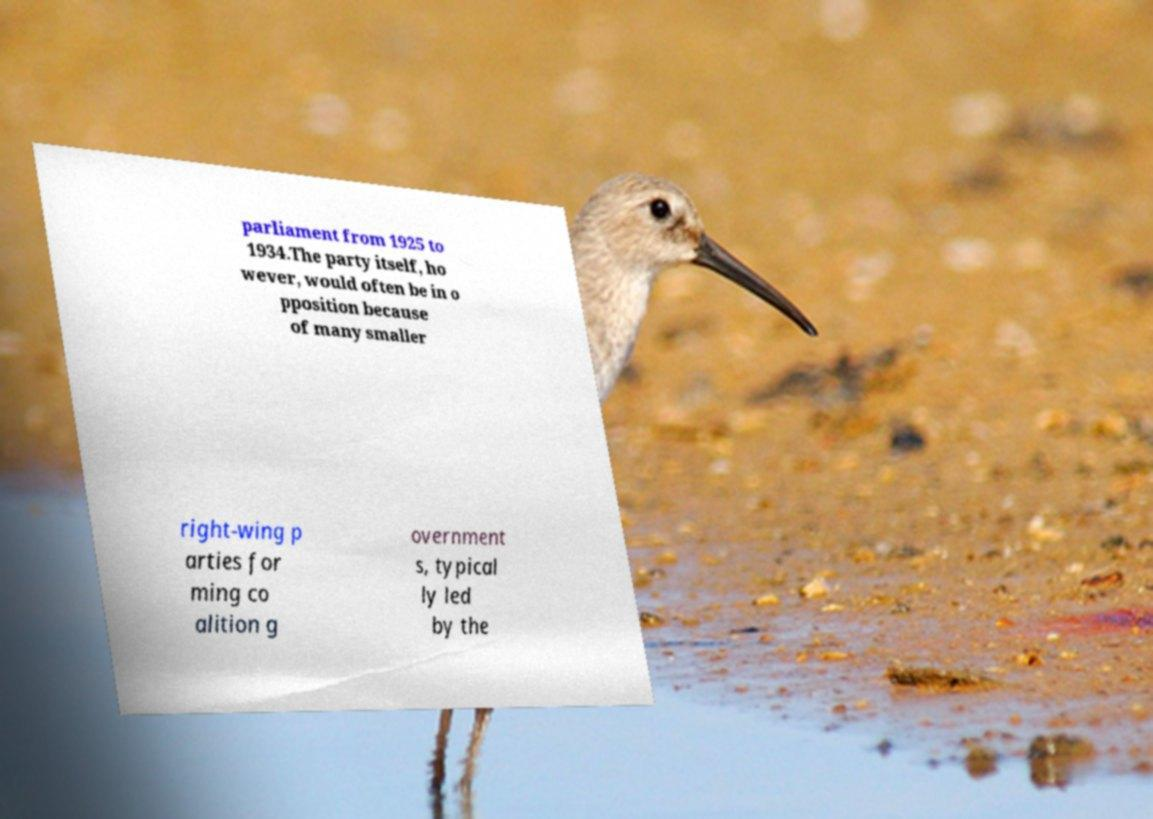Please identify and transcribe the text found in this image. parliament from 1925 to 1934.The party itself, ho wever, would often be in o pposition because of many smaller right-wing p arties for ming co alition g overnment s, typical ly led by the 